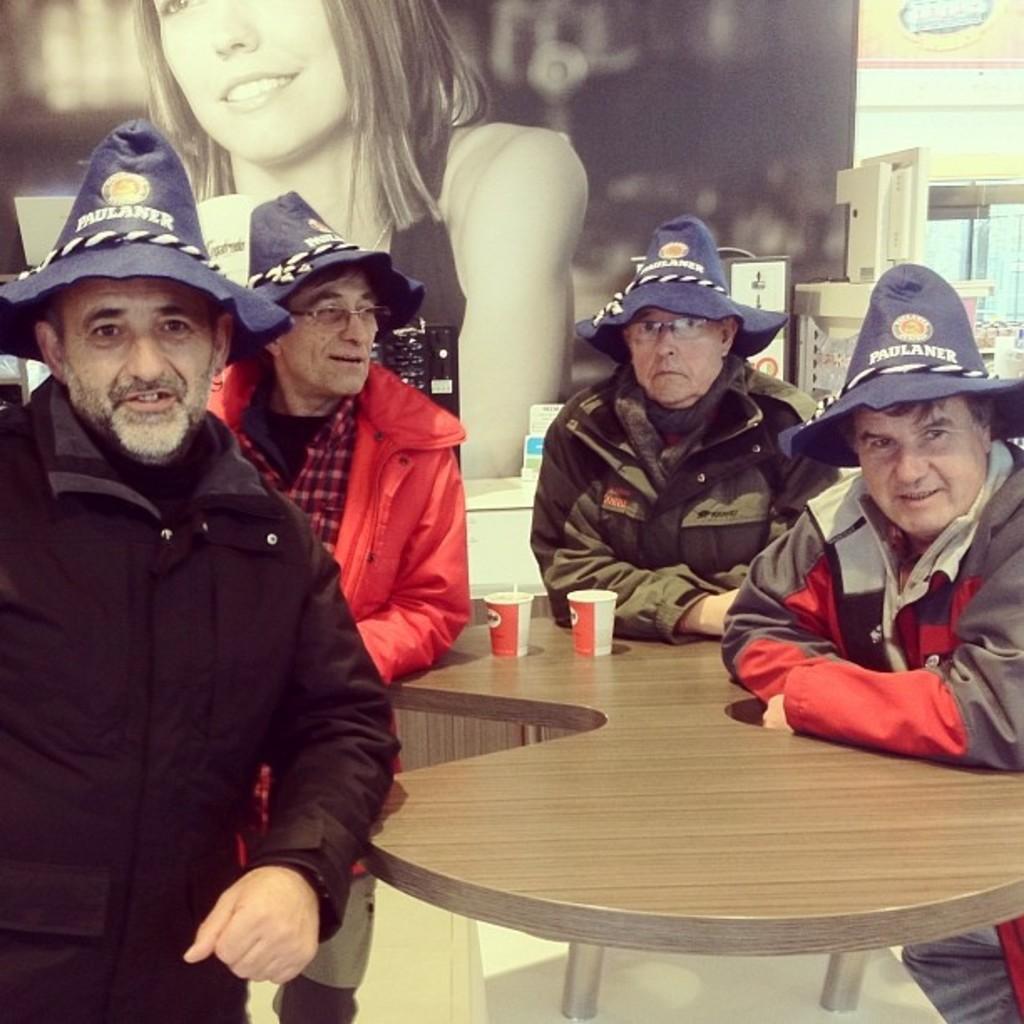In one or two sentences, can you explain what this image depicts? In this image I can see four men and all are wearing hats. All of them are wearing hats. On this table I can see two cups. 